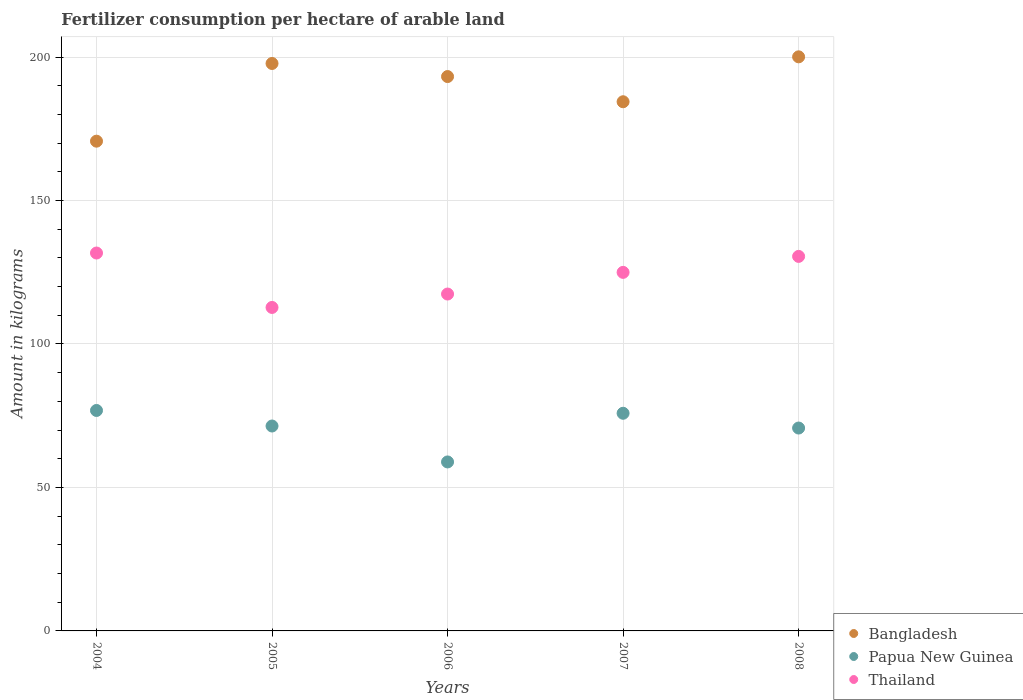What is the amount of fertilizer consumption in Thailand in 2007?
Make the answer very short. 124.95. Across all years, what is the maximum amount of fertilizer consumption in Thailand?
Offer a very short reply. 131.7. Across all years, what is the minimum amount of fertilizer consumption in Thailand?
Your response must be concise. 112.73. In which year was the amount of fertilizer consumption in Bangladesh maximum?
Ensure brevity in your answer.  2008. What is the total amount of fertilizer consumption in Papua New Guinea in the graph?
Your response must be concise. 353.67. What is the difference between the amount of fertilizer consumption in Thailand in 2004 and that in 2007?
Your answer should be very brief. 6.74. What is the difference between the amount of fertilizer consumption in Bangladesh in 2006 and the amount of fertilizer consumption in Thailand in 2004?
Offer a very short reply. 61.49. What is the average amount of fertilizer consumption in Papua New Guinea per year?
Make the answer very short. 70.73. In the year 2006, what is the difference between the amount of fertilizer consumption in Bangladesh and amount of fertilizer consumption in Thailand?
Ensure brevity in your answer.  75.79. What is the ratio of the amount of fertilizer consumption in Bangladesh in 2006 to that in 2008?
Offer a very short reply. 0.97. What is the difference between the highest and the second highest amount of fertilizer consumption in Bangladesh?
Ensure brevity in your answer.  2.32. What is the difference between the highest and the lowest amount of fertilizer consumption in Papua New Guinea?
Keep it short and to the point. 17.94. In how many years, is the amount of fertilizer consumption in Papua New Guinea greater than the average amount of fertilizer consumption in Papua New Guinea taken over all years?
Keep it short and to the point. 3. Does the amount of fertilizer consumption in Thailand monotonically increase over the years?
Your answer should be very brief. No. Is the amount of fertilizer consumption in Papua New Guinea strictly greater than the amount of fertilizer consumption in Thailand over the years?
Offer a terse response. No. How many dotlines are there?
Your answer should be compact. 3. How many years are there in the graph?
Provide a short and direct response. 5. Does the graph contain grids?
Ensure brevity in your answer.  Yes. How many legend labels are there?
Keep it short and to the point. 3. What is the title of the graph?
Make the answer very short. Fertilizer consumption per hectare of arable land. Does "Fiji" appear as one of the legend labels in the graph?
Ensure brevity in your answer.  No. What is the label or title of the X-axis?
Offer a very short reply. Years. What is the label or title of the Y-axis?
Ensure brevity in your answer.  Amount in kilograms. What is the Amount in kilograms in Bangladesh in 2004?
Offer a terse response. 170.67. What is the Amount in kilograms in Papua New Guinea in 2004?
Your answer should be very brief. 76.83. What is the Amount in kilograms of Thailand in 2004?
Your response must be concise. 131.7. What is the Amount in kilograms in Bangladesh in 2005?
Your response must be concise. 197.75. What is the Amount in kilograms of Papua New Guinea in 2005?
Your response must be concise. 71.41. What is the Amount in kilograms in Thailand in 2005?
Make the answer very short. 112.73. What is the Amount in kilograms in Bangladesh in 2006?
Keep it short and to the point. 193.19. What is the Amount in kilograms of Papua New Guinea in 2006?
Make the answer very short. 58.89. What is the Amount in kilograms of Thailand in 2006?
Your response must be concise. 117.4. What is the Amount in kilograms in Bangladesh in 2007?
Your answer should be very brief. 184.41. What is the Amount in kilograms of Papua New Guinea in 2007?
Provide a succinct answer. 75.85. What is the Amount in kilograms of Thailand in 2007?
Offer a terse response. 124.95. What is the Amount in kilograms of Bangladesh in 2008?
Your answer should be very brief. 200.06. What is the Amount in kilograms in Papua New Guinea in 2008?
Keep it short and to the point. 70.7. What is the Amount in kilograms in Thailand in 2008?
Make the answer very short. 130.52. Across all years, what is the maximum Amount in kilograms of Bangladesh?
Offer a very short reply. 200.06. Across all years, what is the maximum Amount in kilograms of Papua New Guinea?
Provide a short and direct response. 76.83. Across all years, what is the maximum Amount in kilograms of Thailand?
Make the answer very short. 131.7. Across all years, what is the minimum Amount in kilograms in Bangladesh?
Give a very brief answer. 170.67. Across all years, what is the minimum Amount in kilograms of Papua New Guinea?
Provide a succinct answer. 58.89. Across all years, what is the minimum Amount in kilograms of Thailand?
Ensure brevity in your answer.  112.73. What is the total Amount in kilograms in Bangladesh in the graph?
Offer a very short reply. 946.09. What is the total Amount in kilograms in Papua New Guinea in the graph?
Your response must be concise. 353.67. What is the total Amount in kilograms of Thailand in the graph?
Offer a terse response. 617.29. What is the difference between the Amount in kilograms in Bangladesh in 2004 and that in 2005?
Provide a succinct answer. -27.08. What is the difference between the Amount in kilograms of Papua New Guinea in 2004 and that in 2005?
Offer a very short reply. 5.42. What is the difference between the Amount in kilograms of Thailand in 2004 and that in 2005?
Keep it short and to the point. 18.97. What is the difference between the Amount in kilograms in Bangladesh in 2004 and that in 2006?
Your response must be concise. -22.52. What is the difference between the Amount in kilograms of Papua New Guinea in 2004 and that in 2006?
Provide a short and direct response. 17.94. What is the difference between the Amount in kilograms of Thailand in 2004 and that in 2006?
Offer a terse response. 14.3. What is the difference between the Amount in kilograms of Bangladesh in 2004 and that in 2007?
Your answer should be compact. -13.74. What is the difference between the Amount in kilograms of Papua New Guinea in 2004 and that in 2007?
Offer a very short reply. 0.98. What is the difference between the Amount in kilograms of Thailand in 2004 and that in 2007?
Keep it short and to the point. 6.74. What is the difference between the Amount in kilograms of Bangladesh in 2004 and that in 2008?
Provide a short and direct response. -29.39. What is the difference between the Amount in kilograms of Papua New Guinea in 2004 and that in 2008?
Keep it short and to the point. 6.12. What is the difference between the Amount in kilograms in Thailand in 2004 and that in 2008?
Make the answer very short. 1.18. What is the difference between the Amount in kilograms of Bangladesh in 2005 and that in 2006?
Offer a very short reply. 4.56. What is the difference between the Amount in kilograms in Papua New Guinea in 2005 and that in 2006?
Ensure brevity in your answer.  12.52. What is the difference between the Amount in kilograms in Thailand in 2005 and that in 2006?
Your answer should be compact. -4.67. What is the difference between the Amount in kilograms in Bangladesh in 2005 and that in 2007?
Provide a short and direct response. 13.34. What is the difference between the Amount in kilograms of Papua New Guinea in 2005 and that in 2007?
Your response must be concise. -4.44. What is the difference between the Amount in kilograms of Thailand in 2005 and that in 2007?
Your answer should be very brief. -12.23. What is the difference between the Amount in kilograms of Bangladesh in 2005 and that in 2008?
Offer a very short reply. -2.32. What is the difference between the Amount in kilograms of Papua New Guinea in 2005 and that in 2008?
Your response must be concise. 0.7. What is the difference between the Amount in kilograms in Thailand in 2005 and that in 2008?
Provide a short and direct response. -17.79. What is the difference between the Amount in kilograms in Bangladesh in 2006 and that in 2007?
Offer a very short reply. 8.78. What is the difference between the Amount in kilograms in Papua New Guinea in 2006 and that in 2007?
Your answer should be compact. -16.96. What is the difference between the Amount in kilograms in Thailand in 2006 and that in 2007?
Your answer should be compact. -7.55. What is the difference between the Amount in kilograms of Bangladesh in 2006 and that in 2008?
Your answer should be compact. -6.87. What is the difference between the Amount in kilograms of Papua New Guinea in 2006 and that in 2008?
Offer a very short reply. -11.82. What is the difference between the Amount in kilograms of Thailand in 2006 and that in 2008?
Provide a short and direct response. -13.12. What is the difference between the Amount in kilograms of Bangladesh in 2007 and that in 2008?
Keep it short and to the point. -15.65. What is the difference between the Amount in kilograms of Papua New Guinea in 2007 and that in 2008?
Your response must be concise. 5.14. What is the difference between the Amount in kilograms in Thailand in 2007 and that in 2008?
Keep it short and to the point. -5.56. What is the difference between the Amount in kilograms of Bangladesh in 2004 and the Amount in kilograms of Papua New Guinea in 2005?
Keep it short and to the point. 99.26. What is the difference between the Amount in kilograms of Bangladesh in 2004 and the Amount in kilograms of Thailand in 2005?
Your answer should be very brief. 57.94. What is the difference between the Amount in kilograms in Papua New Guinea in 2004 and the Amount in kilograms in Thailand in 2005?
Your answer should be very brief. -35.9. What is the difference between the Amount in kilograms of Bangladesh in 2004 and the Amount in kilograms of Papua New Guinea in 2006?
Your response must be concise. 111.78. What is the difference between the Amount in kilograms in Bangladesh in 2004 and the Amount in kilograms in Thailand in 2006?
Your response must be concise. 53.27. What is the difference between the Amount in kilograms of Papua New Guinea in 2004 and the Amount in kilograms of Thailand in 2006?
Ensure brevity in your answer.  -40.57. What is the difference between the Amount in kilograms in Bangladesh in 2004 and the Amount in kilograms in Papua New Guinea in 2007?
Offer a very short reply. 94.82. What is the difference between the Amount in kilograms in Bangladesh in 2004 and the Amount in kilograms in Thailand in 2007?
Provide a short and direct response. 45.72. What is the difference between the Amount in kilograms in Papua New Guinea in 2004 and the Amount in kilograms in Thailand in 2007?
Your answer should be compact. -48.13. What is the difference between the Amount in kilograms of Bangladesh in 2004 and the Amount in kilograms of Papua New Guinea in 2008?
Make the answer very short. 99.97. What is the difference between the Amount in kilograms of Bangladesh in 2004 and the Amount in kilograms of Thailand in 2008?
Provide a succinct answer. 40.15. What is the difference between the Amount in kilograms in Papua New Guinea in 2004 and the Amount in kilograms in Thailand in 2008?
Offer a terse response. -53.69. What is the difference between the Amount in kilograms of Bangladesh in 2005 and the Amount in kilograms of Papua New Guinea in 2006?
Your answer should be compact. 138.86. What is the difference between the Amount in kilograms of Bangladesh in 2005 and the Amount in kilograms of Thailand in 2006?
Ensure brevity in your answer.  80.35. What is the difference between the Amount in kilograms of Papua New Guinea in 2005 and the Amount in kilograms of Thailand in 2006?
Give a very brief answer. -45.99. What is the difference between the Amount in kilograms in Bangladesh in 2005 and the Amount in kilograms in Papua New Guinea in 2007?
Give a very brief answer. 121.9. What is the difference between the Amount in kilograms of Bangladesh in 2005 and the Amount in kilograms of Thailand in 2007?
Make the answer very short. 72.8. What is the difference between the Amount in kilograms of Papua New Guinea in 2005 and the Amount in kilograms of Thailand in 2007?
Your response must be concise. -53.54. What is the difference between the Amount in kilograms of Bangladesh in 2005 and the Amount in kilograms of Papua New Guinea in 2008?
Your answer should be compact. 127.05. What is the difference between the Amount in kilograms in Bangladesh in 2005 and the Amount in kilograms in Thailand in 2008?
Provide a succinct answer. 67.23. What is the difference between the Amount in kilograms of Papua New Guinea in 2005 and the Amount in kilograms of Thailand in 2008?
Provide a succinct answer. -59.11. What is the difference between the Amount in kilograms of Bangladesh in 2006 and the Amount in kilograms of Papua New Guinea in 2007?
Provide a short and direct response. 117.34. What is the difference between the Amount in kilograms in Bangladesh in 2006 and the Amount in kilograms in Thailand in 2007?
Ensure brevity in your answer.  68.24. What is the difference between the Amount in kilograms in Papua New Guinea in 2006 and the Amount in kilograms in Thailand in 2007?
Offer a very short reply. -66.06. What is the difference between the Amount in kilograms in Bangladesh in 2006 and the Amount in kilograms in Papua New Guinea in 2008?
Provide a succinct answer. 122.49. What is the difference between the Amount in kilograms of Bangladesh in 2006 and the Amount in kilograms of Thailand in 2008?
Keep it short and to the point. 62.67. What is the difference between the Amount in kilograms of Papua New Guinea in 2006 and the Amount in kilograms of Thailand in 2008?
Offer a very short reply. -71.63. What is the difference between the Amount in kilograms of Bangladesh in 2007 and the Amount in kilograms of Papua New Guinea in 2008?
Provide a succinct answer. 113.71. What is the difference between the Amount in kilograms of Bangladesh in 2007 and the Amount in kilograms of Thailand in 2008?
Your response must be concise. 53.89. What is the difference between the Amount in kilograms in Papua New Guinea in 2007 and the Amount in kilograms in Thailand in 2008?
Your response must be concise. -54.67. What is the average Amount in kilograms in Bangladesh per year?
Ensure brevity in your answer.  189.22. What is the average Amount in kilograms of Papua New Guinea per year?
Provide a short and direct response. 70.73. What is the average Amount in kilograms of Thailand per year?
Give a very brief answer. 123.46. In the year 2004, what is the difference between the Amount in kilograms of Bangladesh and Amount in kilograms of Papua New Guinea?
Your answer should be compact. 93.85. In the year 2004, what is the difference between the Amount in kilograms in Bangladesh and Amount in kilograms in Thailand?
Your response must be concise. 38.98. In the year 2004, what is the difference between the Amount in kilograms in Papua New Guinea and Amount in kilograms in Thailand?
Keep it short and to the point. -54.87. In the year 2005, what is the difference between the Amount in kilograms in Bangladesh and Amount in kilograms in Papua New Guinea?
Your response must be concise. 126.34. In the year 2005, what is the difference between the Amount in kilograms in Bangladesh and Amount in kilograms in Thailand?
Give a very brief answer. 85.02. In the year 2005, what is the difference between the Amount in kilograms of Papua New Guinea and Amount in kilograms of Thailand?
Make the answer very short. -41.32. In the year 2006, what is the difference between the Amount in kilograms in Bangladesh and Amount in kilograms in Papua New Guinea?
Offer a terse response. 134.3. In the year 2006, what is the difference between the Amount in kilograms of Bangladesh and Amount in kilograms of Thailand?
Keep it short and to the point. 75.79. In the year 2006, what is the difference between the Amount in kilograms in Papua New Guinea and Amount in kilograms in Thailand?
Offer a very short reply. -58.51. In the year 2007, what is the difference between the Amount in kilograms of Bangladesh and Amount in kilograms of Papua New Guinea?
Offer a very short reply. 108.56. In the year 2007, what is the difference between the Amount in kilograms of Bangladesh and Amount in kilograms of Thailand?
Provide a short and direct response. 59.46. In the year 2007, what is the difference between the Amount in kilograms in Papua New Guinea and Amount in kilograms in Thailand?
Provide a short and direct response. -49.1. In the year 2008, what is the difference between the Amount in kilograms of Bangladesh and Amount in kilograms of Papua New Guinea?
Your answer should be very brief. 129.36. In the year 2008, what is the difference between the Amount in kilograms of Bangladesh and Amount in kilograms of Thailand?
Offer a very short reply. 69.55. In the year 2008, what is the difference between the Amount in kilograms of Papua New Guinea and Amount in kilograms of Thailand?
Your response must be concise. -59.81. What is the ratio of the Amount in kilograms in Bangladesh in 2004 to that in 2005?
Offer a very short reply. 0.86. What is the ratio of the Amount in kilograms of Papua New Guinea in 2004 to that in 2005?
Offer a very short reply. 1.08. What is the ratio of the Amount in kilograms in Thailand in 2004 to that in 2005?
Offer a very short reply. 1.17. What is the ratio of the Amount in kilograms in Bangladesh in 2004 to that in 2006?
Your answer should be very brief. 0.88. What is the ratio of the Amount in kilograms in Papua New Guinea in 2004 to that in 2006?
Keep it short and to the point. 1.3. What is the ratio of the Amount in kilograms of Thailand in 2004 to that in 2006?
Your answer should be very brief. 1.12. What is the ratio of the Amount in kilograms in Bangladesh in 2004 to that in 2007?
Your response must be concise. 0.93. What is the ratio of the Amount in kilograms in Papua New Guinea in 2004 to that in 2007?
Your answer should be very brief. 1.01. What is the ratio of the Amount in kilograms in Thailand in 2004 to that in 2007?
Provide a succinct answer. 1.05. What is the ratio of the Amount in kilograms in Bangladesh in 2004 to that in 2008?
Keep it short and to the point. 0.85. What is the ratio of the Amount in kilograms in Papua New Guinea in 2004 to that in 2008?
Ensure brevity in your answer.  1.09. What is the ratio of the Amount in kilograms in Thailand in 2004 to that in 2008?
Keep it short and to the point. 1.01. What is the ratio of the Amount in kilograms of Bangladesh in 2005 to that in 2006?
Your response must be concise. 1.02. What is the ratio of the Amount in kilograms of Papua New Guinea in 2005 to that in 2006?
Make the answer very short. 1.21. What is the ratio of the Amount in kilograms of Thailand in 2005 to that in 2006?
Make the answer very short. 0.96. What is the ratio of the Amount in kilograms in Bangladesh in 2005 to that in 2007?
Provide a short and direct response. 1.07. What is the ratio of the Amount in kilograms of Papua New Guinea in 2005 to that in 2007?
Keep it short and to the point. 0.94. What is the ratio of the Amount in kilograms in Thailand in 2005 to that in 2007?
Your answer should be compact. 0.9. What is the ratio of the Amount in kilograms of Bangladesh in 2005 to that in 2008?
Your answer should be very brief. 0.99. What is the ratio of the Amount in kilograms in Papua New Guinea in 2005 to that in 2008?
Ensure brevity in your answer.  1.01. What is the ratio of the Amount in kilograms in Thailand in 2005 to that in 2008?
Keep it short and to the point. 0.86. What is the ratio of the Amount in kilograms of Bangladesh in 2006 to that in 2007?
Your response must be concise. 1.05. What is the ratio of the Amount in kilograms in Papua New Guinea in 2006 to that in 2007?
Keep it short and to the point. 0.78. What is the ratio of the Amount in kilograms in Thailand in 2006 to that in 2007?
Provide a short and direct response. 0.94. What is the ratio of the Amount in kilograms in Bangladesh in 2006 to that in 2008?
Your response must be concise. 0.97. What is the ratio of the Amount in kilograms in Papua New Guinea in 2006 to that in 2008?
Your response must be concise. 0.83. What is the ratio of the Amount in kilograms in Thailand in 2006 to that in 2008?
Ensure brevity in your answer.  0.9. What is the ratio of the Amount in kilograms in Bangladesh in 2007 to that in 2008?
Offer a terse response. 0.92. What is the ratio of the Amount in kilograms in Papua New Guinea in 2007 to that in 2008?
Make the answer very short. 1.07. What is the ratio of the Amount in kilograms in Thailand in 2007 to that in 2008?
Your response must be concise. 0.96. What is the difference between the highest and the second highest Amount in kilograms of Bangladesh?
Your answer should be very brief. 2.32. What is the difference between the highest and the second highest Amount in kilograms of Papua New Guinea?
Your response must be concise. 0.98. What is the difference between the highest and the second highest Amount in kilograms in Thailand?
Offer a terse response. 1.18. What is the difference between the highest and the lowest Amount in kilograms of Bangladesh?
Your answer should be very brief. 29.39. What is the difference between the highest and the lowest Amount in kilograms in Papua New Guinea?
Provide a succinct answer. 17.94. What is the difference between the highest and the lowest Amount in kilograms of Thailand?
Offer a terse response. 18.97. 